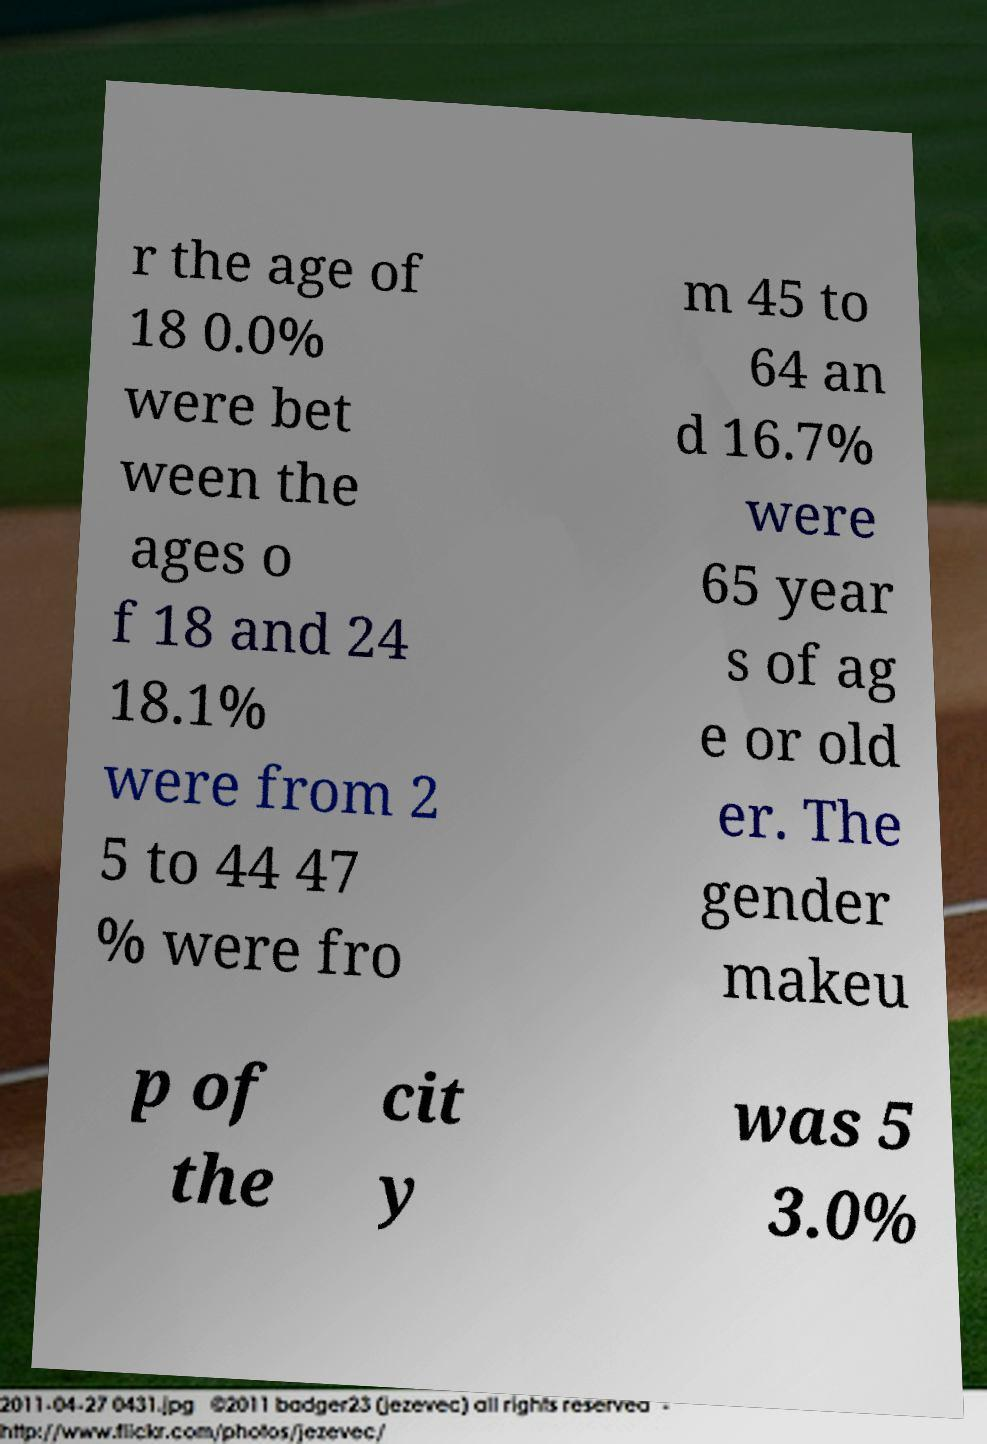Could you assist in decoding the text presented in this image and type it out clearly? r the age of 18 0.0% were bet ween the ages o f 18 and 24 18.1% were from 2 5 to 44 47 % were fro m 45 to 64 an d 16.7% were 65 year s of ag e or old er. The gender makeu p of the cit y was 5 3.0% 